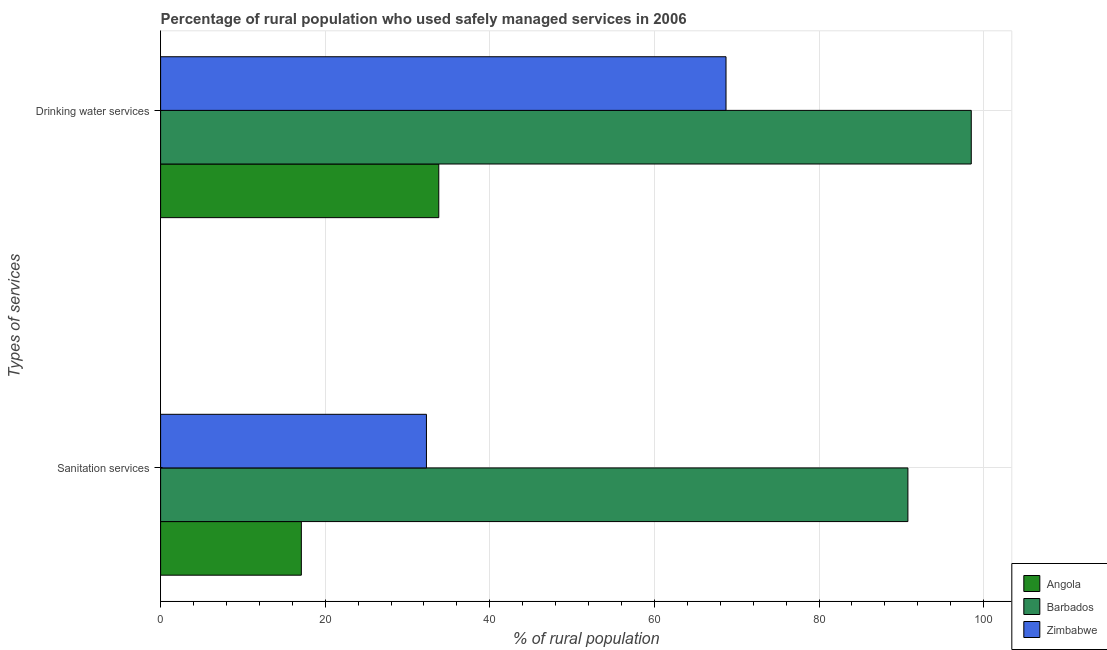How many different coloured bars are there?
Ensure brevity in your answer.  3. What is the label of the 2nd group of bars from the top?
Your answer should be compact. Sanitation services. What is the percentage of rural population who used drinking water services in Barbados?
Your response must be concise. 98.5. Across all countries, what is the maximum percentage of rural population who used drinking water services?
Provide a succinct answer. 98.5. Across all countries, what is the minimum percentage of rural population who used drinking water services?
Provide a short and direct response. 33.8. In which country was the percentage of rural population who used sanitation services maximum?
Give a very brief answer. Barbados. In which country was the percentage of rural population who used sanitation services minimum?
Offer a terse response. Angola. What is the total percentage of rural population who used drinking water services in the graph?
Make the answer very short. 201. What is the difference between the percentage of rural population who used sanitation services in Angola and that in Barbados?
Your response must be concise. -73.7. What is the difference between the percentage of rural population who used drinking water services in Barbados and the percentage of rural population who used sanitation services in Zimbabwe?
Ensure brevity in your answer.  66.2. What is the average percentage of rural population who used sanitation services per country?
Provide a succinct answer. 46.73. What is the difference between the percentage of rural population who used sanitation services and percentage of rural population who used drinking water services in Zimbabwe?
Your answer should be compact. -36.4. What is the ratio of the percentage of rural population who used sanitation services in Angola to that in Zimbabwe?
Keep it short and to the point. 0.53. What does the 1st bar from the top in Sanitation services represents?
Your answer should be very brief. Zimbabwe. What does the 1st bar from the bottom in Drinking water services represents?
Ensure brevity in your answer.  Angola. How many bars are there?
Provide a short and direct response. 6. Are all the bars in the graph horizontal?
Offer a terse response. Yes. What is the difference between two consecutive major ticks on the X-axis?
Your response must be concise. 20. Are the values on the major ticks of X-axis written in scientific E-notation?
Offer a terse response. No. Does the graph contain any zero values?
Your answer should be compact. No. Where does the legend appear in the graph?
Give a very brief answer. Bottom right. How many legend labels are there?
Your answer should be very brief. 3. What is the title of the graph?
Provide a short and direct response. Percentage of rural population who used safely managed services in 2006. What is the label or title of the X-axis?
Make the answer very short. % of rural population. What is the label or title of the Y-axis?
Ensure brevity in your answer.  Types of services. What is the % of rural population in Barbados in Sanitation services?
Make the answer very short. 90.8. What is the % of rural population in Zimbabwe in Sanitation services?
Make the answer very short. 32.3. What is the % of rural population of Angola in Drinking water services?
Your answer should be compact. 33.8. What is the % of rural population of Barbados in Drinking water services?
Offer a very short reply. 98.5. What is the % of rural population in Zimbabwe in Drinking water services?
Make the answer very short. 68.7. Across all Types of services, what is the maximum % of rural population of Angola?
Make the answer very short. 33.8. Across all Types of services, what is the maximum % of rural population of Barbados?
Give a very brief answer. 98.5. Across all Types of services, what is the maximum % of rural population of Zimbabwe?
Provide a short and direct response. 68.7. Across all Types of services, what is the minimum % of rural population of Barbados?
Provide a succinct answer. 90.8. Across all Types of services, what is the minimum % of rural population in Zimbabwe?
Make the answer very short. 32.3. What is the total % of rural population in Angola in the graph?
Keep it short and to the point. 50.9. What is the total % of rural population of Barbados in the graph?
Your answer should be compact. 189.3. What is the total % of rural population in Zimbabwe in the graph?
Ensure brevity in your answer.  101. What is the difference between the % of rural population in Angola in Sanitation services and that in Drinking water services?
Keep it short and to the point. -16.7. What is the difference between the % of rural population of Zimbabwe in Sanitation services and that in Drinking water services?
Offer a very short reply. -36.4. What is the difference between the % of rural population in Angola in Sanitation services and the % of rural population in Barbados in Drinking water services?
Provide a succinct answer. -81.4. What is the difference between the % of rural population of Angola in Sanitation services and the % of rural population of Zimbabwe in Drinking water services?
Keep it short and to the point. -51.6. What is the difference between the % of rural population of Barbados in Sanitation services and the % of rural population of Zimbabwe in Drinking water services?
Keep it short and to the point. 22.1. What is the average % of rural population in Angola per Types of services?
Offer a terse response. 25.45. What is the average % of rural population of Barbados per Types of services?
Provide a short and direct response. 94.65. What is the average % of rural population of Zimbabwe per Types of services?
Offer a terse response. 50.5. What is the difference between the % of rural population of Angola and % of rural population of Barbados in Sanitation services?
Provide a succinct answer. -73.7. What is the difference between the % of rural population in Angola and % of rural population in Zimbabwe in Sanitation services?
Your answer should be compact. -15.2. What is the difference between the % of rural population in Barbados and % of rural population in Zimbabwe in Sanitation services?
Ensure brevity in your answer.  58.5. What is the difference between the % of rural population of Angola and % of rural population of Barbados in Drinking water services?
Provide a succinct answer. -64.7. What is the difference between the % of rural population in Angola and % of rural population in Zimbabwe in Drinking water services?
Your answer should be compact. -34.9. What is the difference between the % of rural population of Barbados and % of rural population of Zimbabwe in Drinking water services?
Offer a terse response. 29.8. What is the ratio of the % of rural population in Angola in Sanitation services to that in Drinking water services?
Make the answer very short. 0.51. What is the ratio of the % of rural population in Barbados in Sanitation services to that in Drinking water services?
Your answer should be compact. 0.92. What is the ratio of the % of rural population in Zimbabwe in Sanitation services to that in Drinking water services?
Provide a succinct answer. 0.47. What is the difference between the highest and the second highest % of rural population of Barbados?
Your response must be concise. 7.7. What is the difference between the highest and the second highest % of rural population of Zimbabwe?
Keep it short and to the point. 36.4. What is the difference between the highest and the lowest % of rural population in Barbados?
Your answer should be compact. 7.7. What is the difference between the highest and the lowest % of rural population of Zimbabwe?
Ensure brevity in your answer.  36.4. 